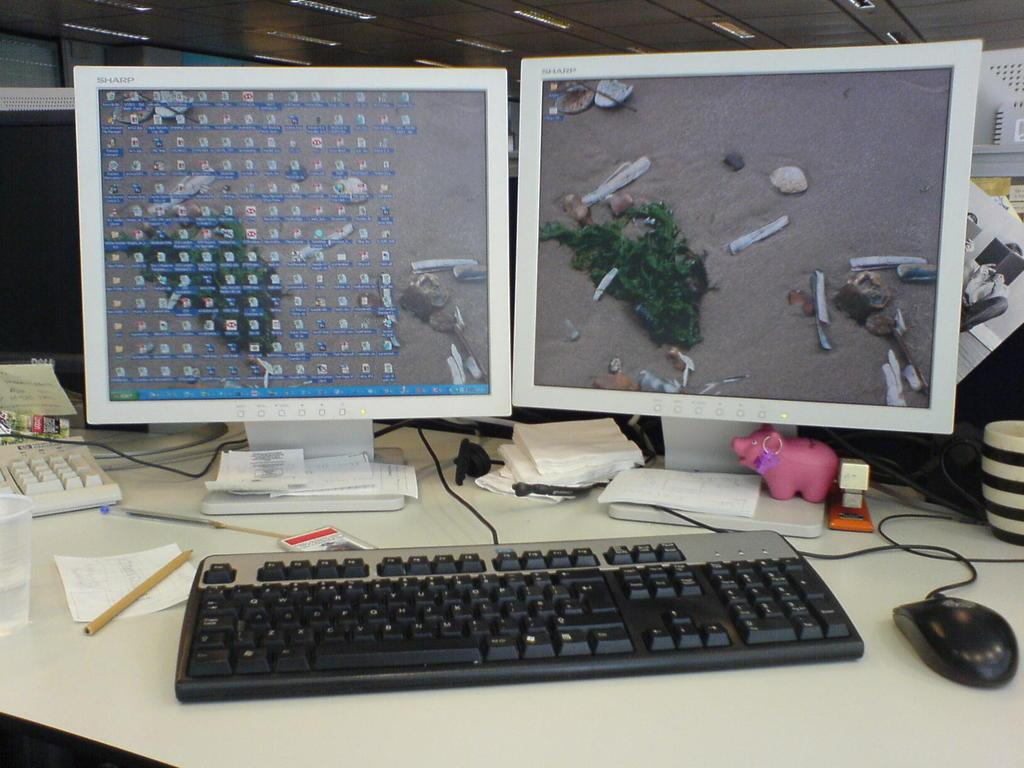How many computer systems are on the table in the image? There are two computer systems on the table in the image. What input devices are visible on the table? There is a keyboard and a mouse on the table. What type of object is present on the table that is not related to technology? There is a small toy on the table. What items might be used for cleaning or wiping in the image? Tissue papers are on the table for cleaning or wiping. What is the purpose of the glass on the table? The purpose of the glass on the table is not clear from the image, but it could be used for holding a beverage or other liquid. What is the paper on the table used for? The paper on the table might be used for writing or printing documents. What items might be used for writing in the image? There are pens on the table that can be used for writing. What type of coach is sitting next to the computer systems in the image? There is no coach present in the image; it features computer systems, a keyboard, a mouse, a small toy, tissue papers, a glass, a paper, and pens on a table. 